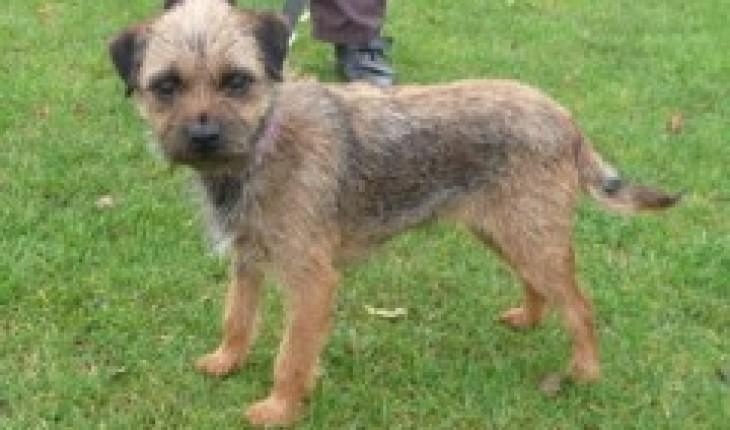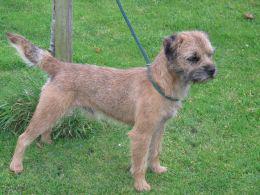The first image is the image on the left, the second image is the image on the right. For the images shown, is this caption "a dog has a leash on in the right image" true? Answer yes or no. Yes. The first image is the image on the left, the second image is the image on the right. Evaluate the accuracy of this statement regarding the images: "In one of the images there are three dogs.". Is it true? Answer yes or no. No. 